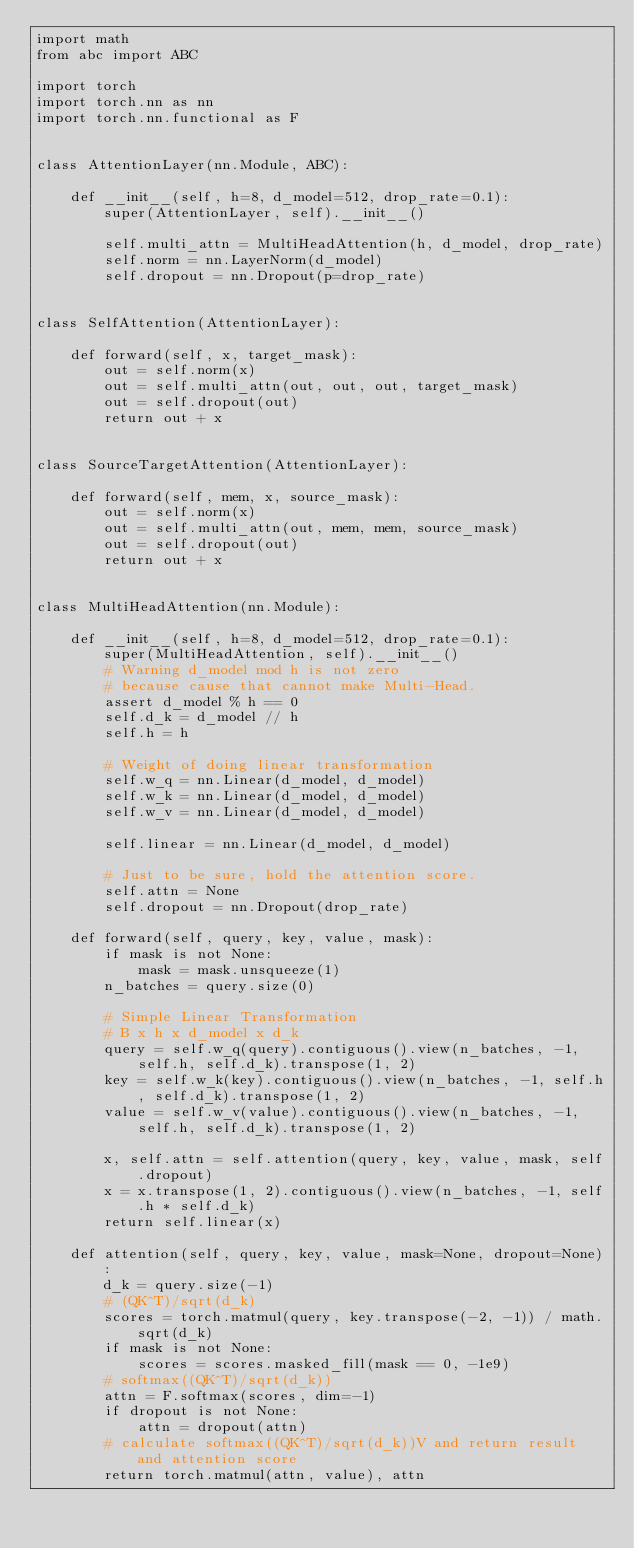<code> <loc_0><loc_0><loc_500><loc_500><_Python_>import math
from abc import ABC

import torch
import torch.nn as nn
import torch.nn.functional as F


class AttentionLayer(nn.Module, ABC):

    def __init__(self, h=8, d_model=512, drop_rate=0.1):
        super(AttentionLayer, self).__init__()

        self.multi_attn = MultiHeadAttention(h, d_model, drop_rate)
        self.norm = nn.LayerNorm(d_model)
        self.dropout = nn.Dropout(p=drop_rate)


class SelfAttention(AttentionLayer):

    def forward(self, x, target_mask):
        out = self.norm(x)
        out = self.multi_attn(out, out, out, target_mask)
        out = self.dropout(out)
        return out + x


class SourceTargetAttention(AttentionLayer):

    def forward(self, mem, x, source_mask):
        out = self.norm(x)
        out = self.multi_attn(out, mem, mem, source_mask)
        out = self.dropout(out)
        return out + x


class MultiHeadAttention(nn.Module):

    def __init__(self, h=8, d_model=512, drop_rate=0.1):
        super(MultiHeadAttention, self).__init__()
        # Warning d_model mod h is not zero
        # because cause that cannot make Multi-Head.
        assert d_model % h == 0
        self.d_k = d_model // h
        self.h = h

        # Weight of doing linear transformation
        self.w_q = nn.Linear(d_model, d_model)
        self.w_k = nn.Linear(d_model, d_model)
        self.w_v = nn.Linear(d_model, d_model)

        self.linear = nn.Linear(d_model, d_model)

        # Just to be sure, hold the attention score.
        self.attn = None
        self.dropout = nn.Dropout(drop_rate)

    def forward(self, query, key, value, mask):
        if mask is not None:
            mask = mask.unsqueeze(1)
        n_batches = query.size(0)

        # Simple Linear Transformation
        # B x h x d_model x d_k
        query = self.w_q(query).contiguous().view(n_batches, -1, self.h, self.d_k).transpose(1, 2)
        key = self.w_k(key).contiguous().view(n_batches, -1, self.h, self.d_k).transpose(1, 2)
        value = self.w_v(value).contiguous().view(n_batches, -1, self.h, self.d_k).transpose(1, 2)

        x, self.attn = self.attention(query, key, value, mask, self.dropout)
        x = x.transpose(1, 2).contiguous().view(n_batches, -1, self.h * self.d_k)
        return self.linear(x)

    def attention(self, query, key, value, mask=None, dropout=None):
        d_k = query.size(-1)
        # (QK^T)/sqrt(d_k)
        scores = torch.matmul(query, key.transpose(-2, -1)) / math.sqrt(d_k)
        if mask is not None:
            scores = scores.masked_fill(mask == 0, -1e9)
        # softmax((QK^T)/sqrt(d_k))
        attn = F.softmax(scores, dim=-1)
        if dropout is not None:
            attn = dropout(attn)
        # calculate softmax((QK^T)/sqrt(d_k))V and return result and attention score
        return torch.matmul(attn, value), attn
</code> 